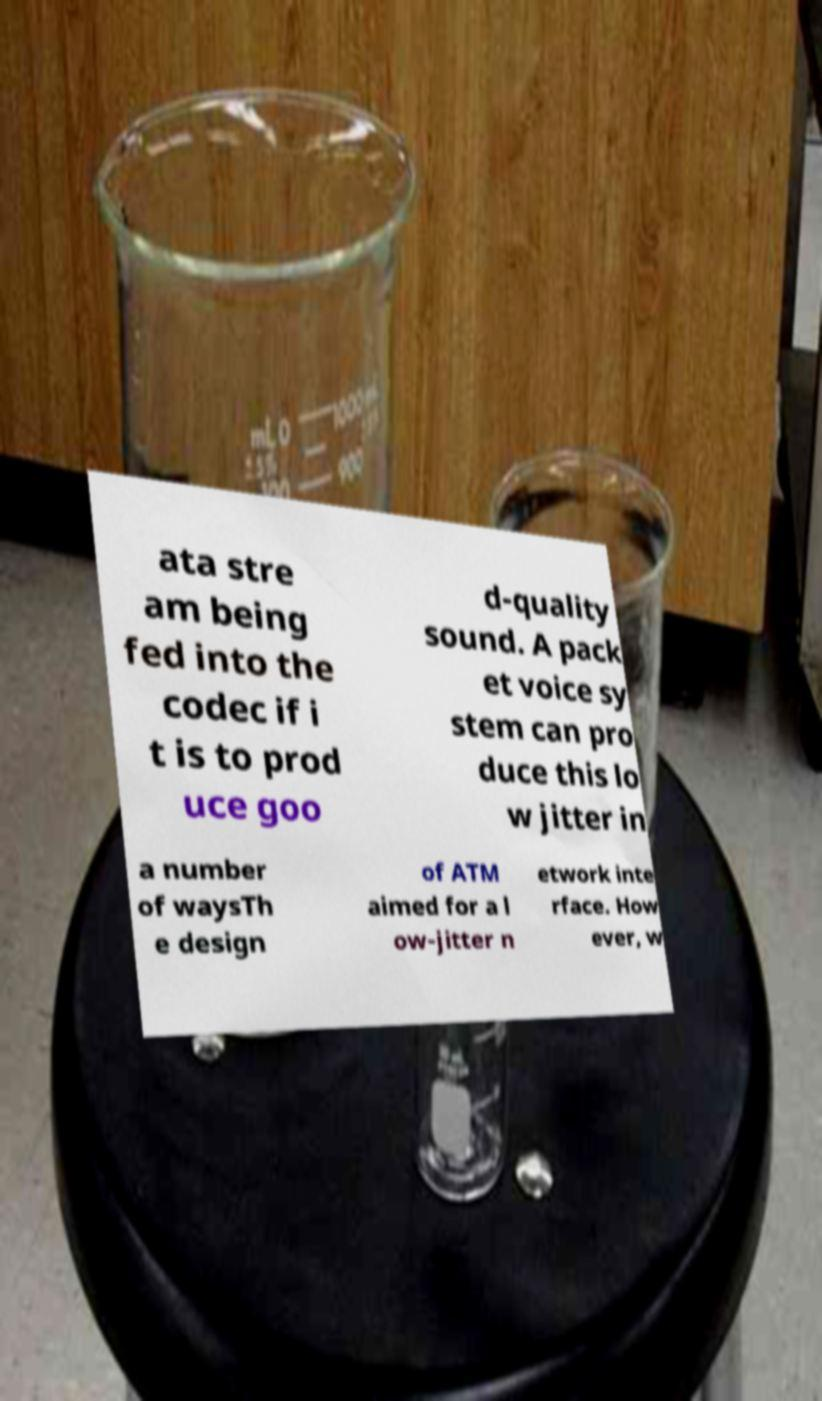Please read and relay the text visible in this image. What does it say? ata stre am being fed into the codec if i t is to prod uce goo d-quality sound. A pack et voice sy stem can pro duce this lo w jitter in a number of waysTh e design of ATM aimed for a l ow-jitter n etwork inte rface. How ever, w 